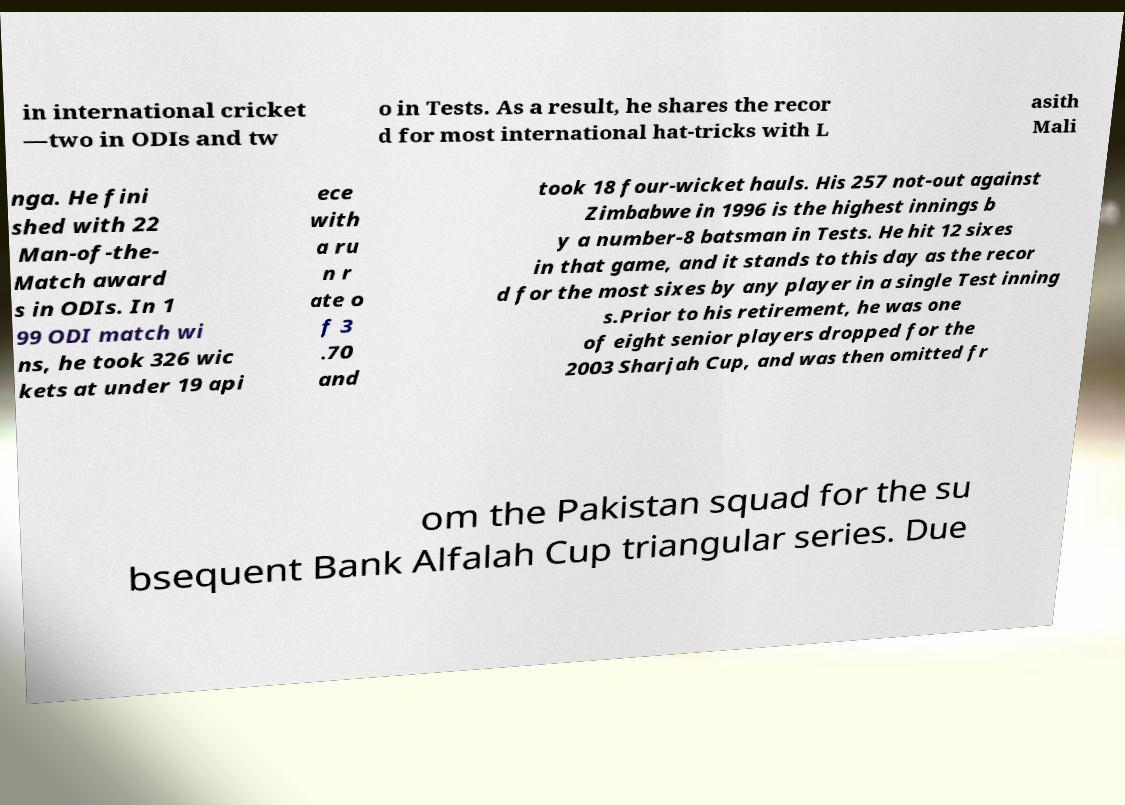Can you accurately transcribe the text from the provided image for me? in international cricket —two in ODIs and tw o in Tests. As a result, he shares the recor d for most international hat-tricks with L asith Mali nga. He fini shed with 22 Man-of-the- Match award s in ODIs. In 1 99 ODI match wi ns, he took 326 wic kets at under 19 api ece with a ru n r ate o f 3 .70 and took 18 four-wicket hauls. His 257 not-out against Zimbabwe in 1996 is the highest innings b y a number-8 batsman in Tests. He hit 12 sixes in that game, and it stands to this day as the recor d for the most sixes by any player in a single Test inning s.Prior to his retirement, he was one of eight senior players dropped for the 2003 Sharjah Cup, and was then omitted fr om the Pakistan squad for the su bsequent Bank Alfalah Cup triangular series. Due 